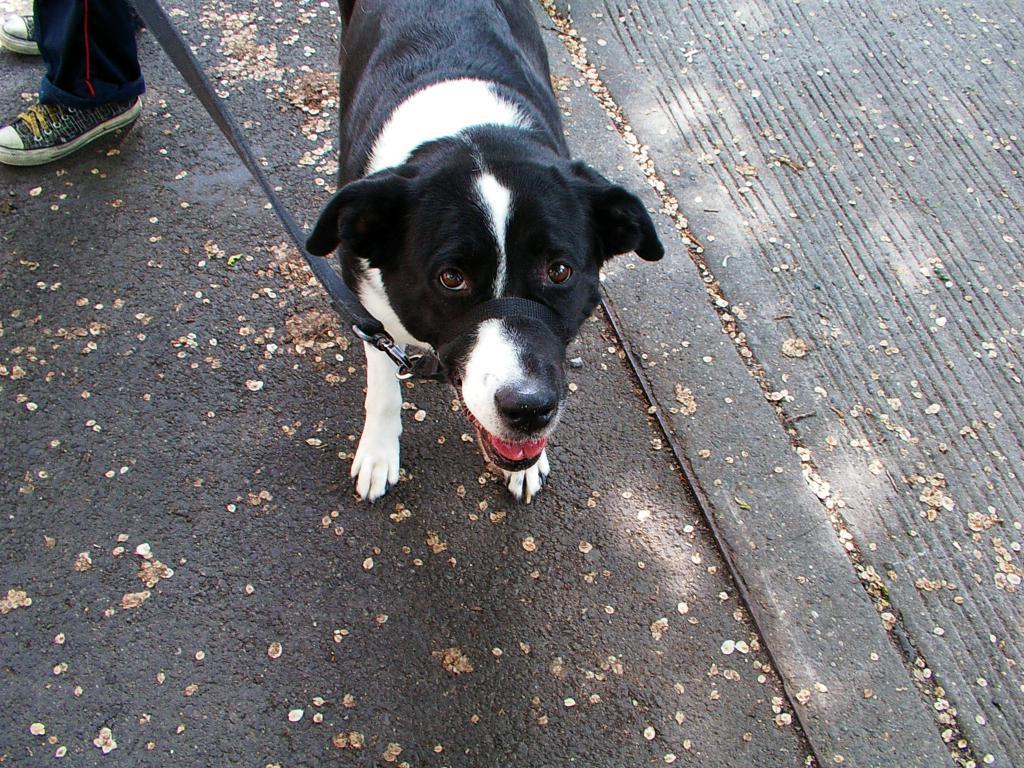In one or two sentences, can you explain what this image depicts? In this picture we can see a dog and a black belt and we can see shoes. This is a road. 